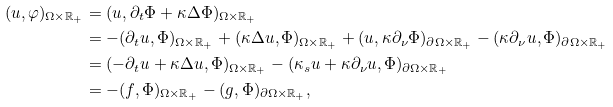Convert formula to latex. <formula><loc_0><loc_0><loc_500><loc_500>( u , \varphi ) _ { \Omega \times \mathbb { R } _ { + } } & = ( u , \partial _ { t } \Phi + \kappa \Delta \Phi ) _ { \Omega \times \mathbb { R } _ { + } } \\ & = - ( \partial _ { t } u , \Phi ) _ { \Omega \times \mathbb { R } _ { + } } + ( \kappa \Delta u , \Phi ) _ { \Omega \times \mathbb { R } _ { + } } + ( u , \kappa \partial _ { \nu } \Phi ) _ { \partial \Omega \times \mathbb { R } _ { + } } - ( \kappa \partial _ { \nu } u , \Phi ) _ { \partial \Omega \times \mathbb { R } _ { + } } \\ & = ( - \partial _ { t } u + \kappa \Delta u , \Phi ) _ { \Omega \times \mathbb { R } _ { + } } - ( \kappa _ { s } u + \kappa \partial _ { \nu } u , \Phi ) _ { \partial \Omega \times \mathbb { R } _ { + } } \\ & = - ( f , \Phi ) _ { \Omega \times \mathbb { R } _ { + } } - ( g , \Phi ) _ { \partial \Omega \times \mathbb { R } _ { + } } ,</formula> 